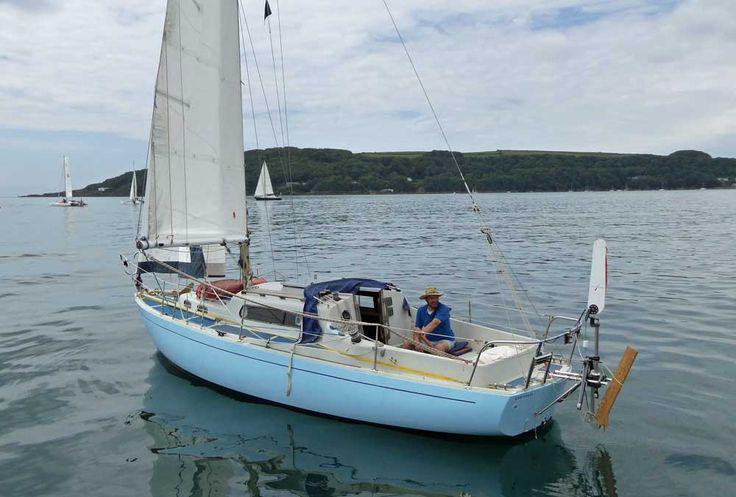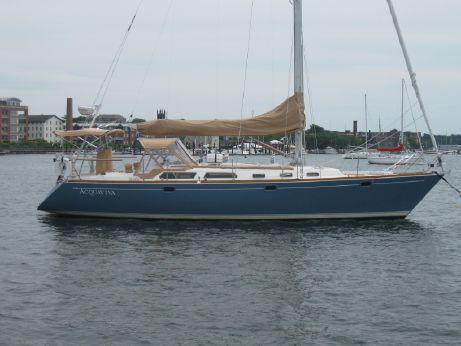The first image is the image on the left, the second image is the image on the right. Given the left and right images, does the statement "Both vessels are moving in the same direction." hold true? Answer yes or no. No. The first image is the image on the left, the second image is the image on the right. Given the left and right images, does the statement "The sails of at least one boat are furled in tan canvas." hold true? Answer yes or no. Yes. 